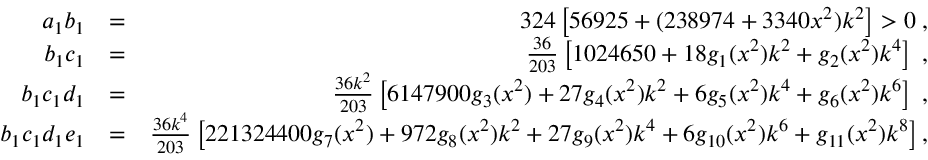<formula> <loc_0><loc_0><loc_500><loc_500>\begin{array} { r l r } { a _ { 1 } b _ { 1 } } & { = } & { 3 2 4 \left [ 5 6 9 2 5 + ( 2 3 8 9 7 4 + 3 3 4 0 x ^ { 2 } ) k ^ { 2 } \right ] > 0 \, , } \\ { b _ { 1 } c _ { 1 } } & { = } & { \frac { 3 6 } { 2 0 3 } \left [ 1 0 2 4 6 5 0 + 1 8 g _ { 1 } ( x ^ { 2 } ) k ^ { 2 } + g _ { 2 } ( x ^ { 2 } ) k ^ { 4 } \right ] \, , } \\ { b _ { 1 } c _ { 1 } d _ { 1 } } & { = } & { \frac { 3 6 k ^ { 2 } } { 2 0 3 } \left [ 6 1 4 7 9 0 0 g _ { 3 } ( x ^ { 2 } ) + 2 7 g _ { 4 } ( x ^ { 2 } ) k ^ { 2 } + 6 g _ { 5 } ( x ^ { 2 } ) k ^ { 4 } + g _ { 6 } ( x ^ { 2 } ) k ^ { 6 } \right ] \, , } \\ { b _ { 1 } c _ { 1 } d _ { 1 } e _ { 1 } } & { = } & { \frac { 3 6 k ^ { 4 } } { 2 0 3 } \left [ 2 2 1 3 2 4 4 0 0 g _ { 7 } ( x ^ { 2 } ) + 9 7 2 g _ { 8 } ( x ^ { 2 } ) k ^ { 2 } + 2 7 g _ { 9 } ( x ^ { 2 } ) k ^ { 4 } + 6 g _ { 1 0 } ( x ^ { 2 } ) k ^ { 6 } + g _ { 1 1 } ( x ^ { 2 } ) k ^ { 8 } \right ] , } \end{array}</formula> 